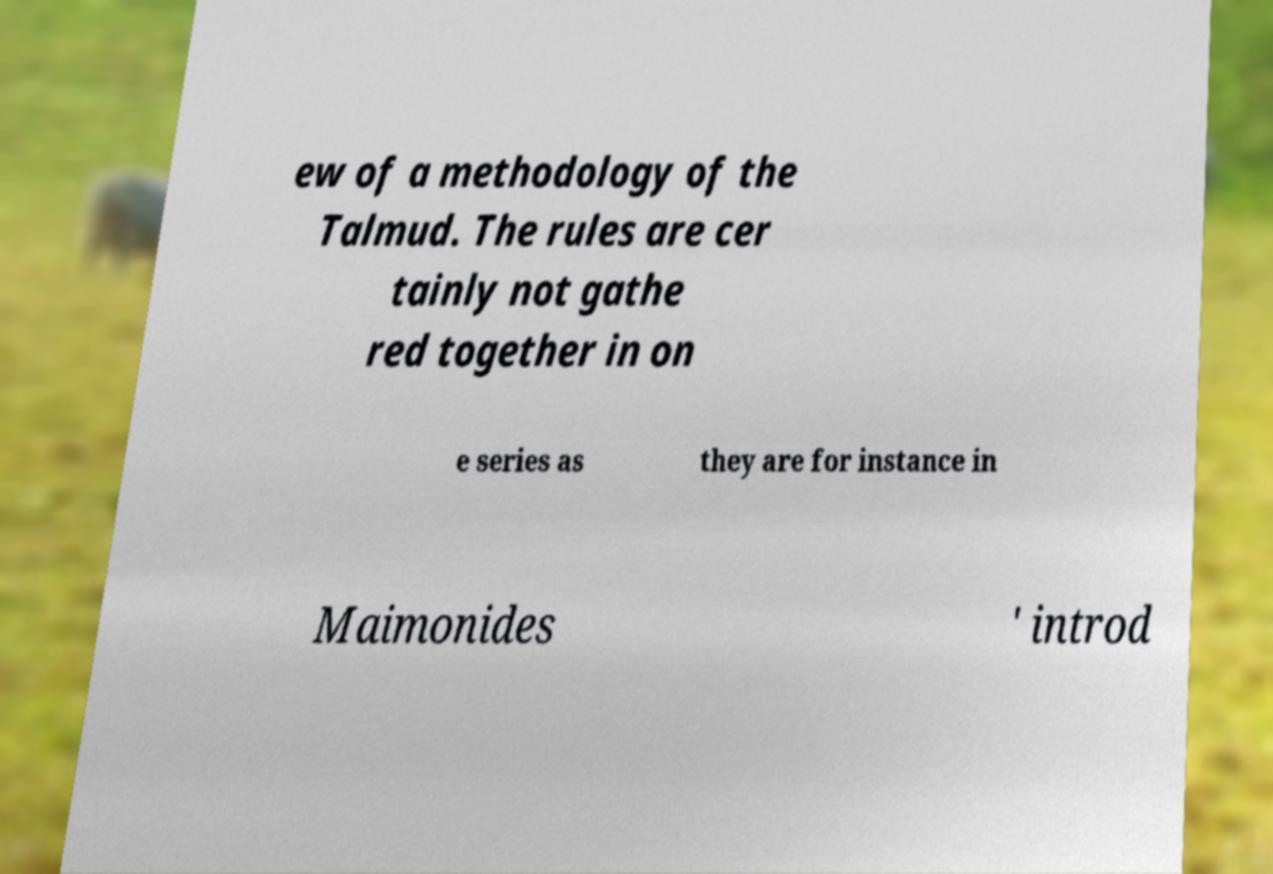Can you read and provide the text displayed in the image?This photo seems to have some interesting text. Can you extract and type it out for me? ew of a methodology of the Talmud. The rules are cer tainly not gathe red together in on e series as they are for instance in Maimonides ' introd 